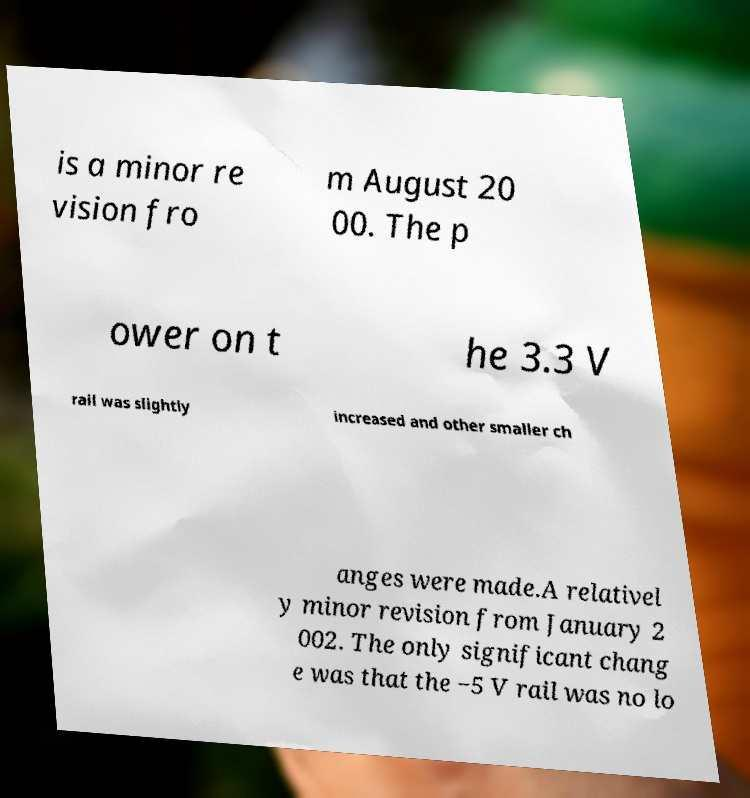For documentation purposes, I need the text within this image transcribed. Could you provide that? is a minor re vision fro m August 20 00. The p ower on t he 3.3 V rail was slightly increased and other smaller ch anges were made.A relativel y minor revision from January 2 002. The only significant chang e was that the −5 V rail was no lo 